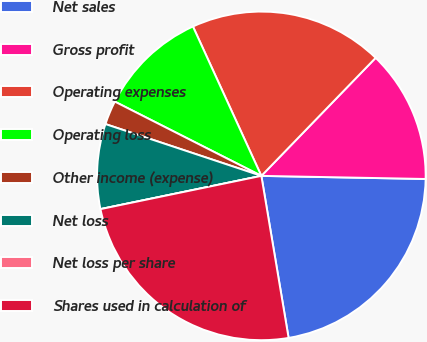<chart> <loc_0><loc_0><loc_500><loc_500><pie_chart><fcel>Net sales<fcel>Gross profit<fcel>Operating expenses<fcel>Operating loss<fcel>Other income (expense)<fcel>Net loss<fcel>Net loss per share<fcel>Shares used in calculation of<nl><fcel>22.05%<fcel>13.06%<fcel>19.08%<fcel>10.7%<fcel>2.36%<fcel>8.35%<fcel>0.0%<fcel>24.41%<nl></chart> 